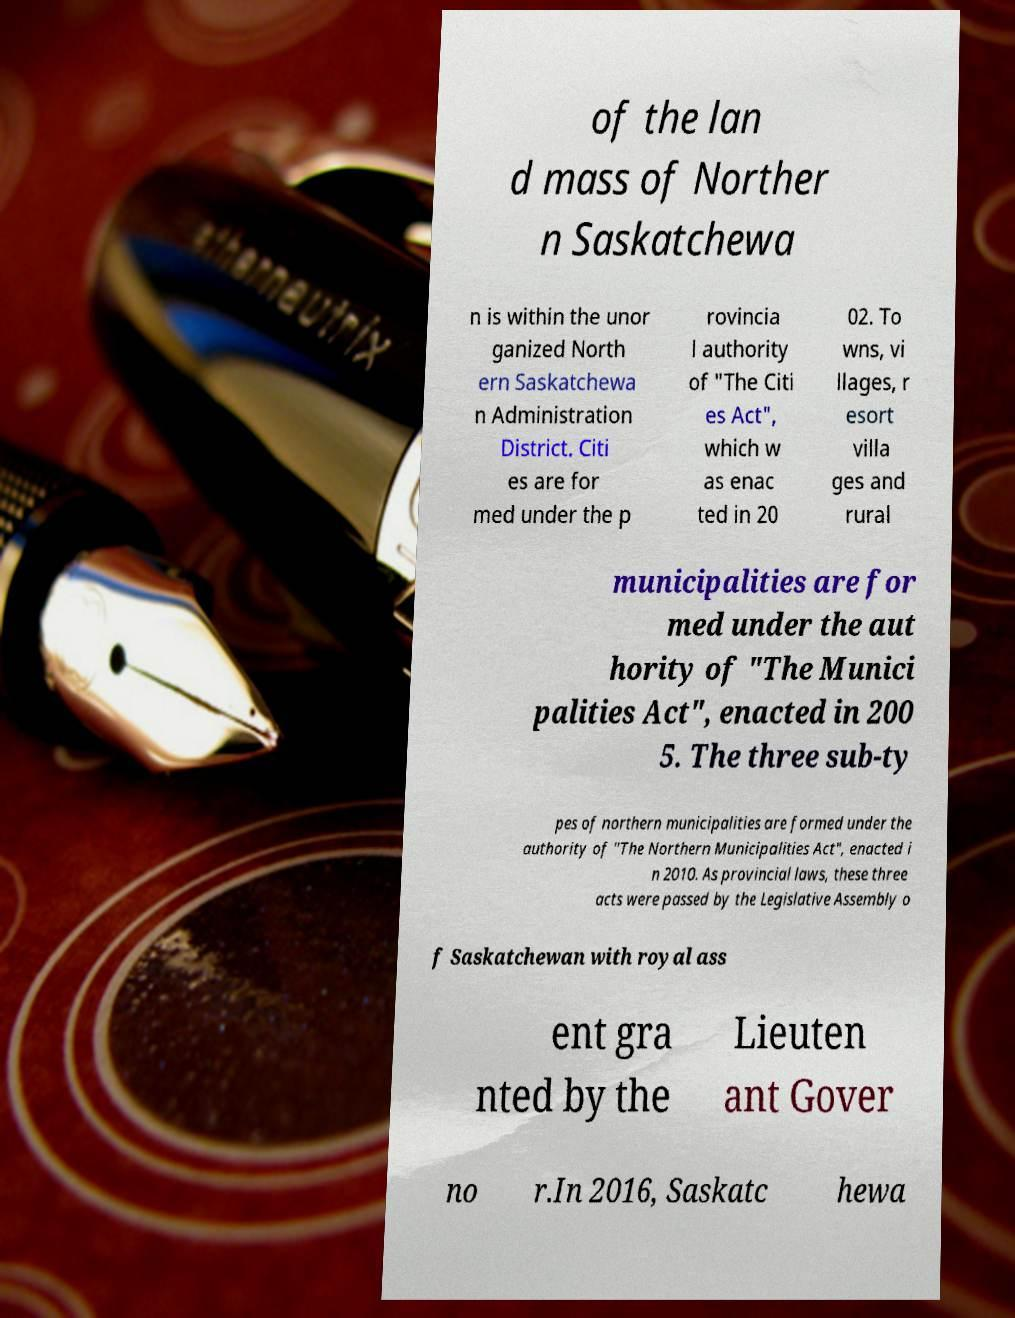Could you assist in decoding the text presented in this image and type it out clearly? of the lan d mass of Norther n Saskatchewa n is within the unor ganized North ern Saskatchewa n Administration District. Citi es are for med under the p rovincia l authority of "The Citi es Act", which w as enac ted in 20 02. To wns, vi llages, r esort villa ges and rural municipalities are for med under the aut hority of "The Munici palities Act", enacted in 200 5. The three sub-ty pes of northern municipalities are formed under the authority of "The Northern Municipalities Act", enacted i n 2010. As provincial laws, these three acts were passed by the Legislative Assembly o f Saskatchewan with royal ass ent gra nted by the Lieuten ant Gover no r.In 2016, Saskatc hewa 